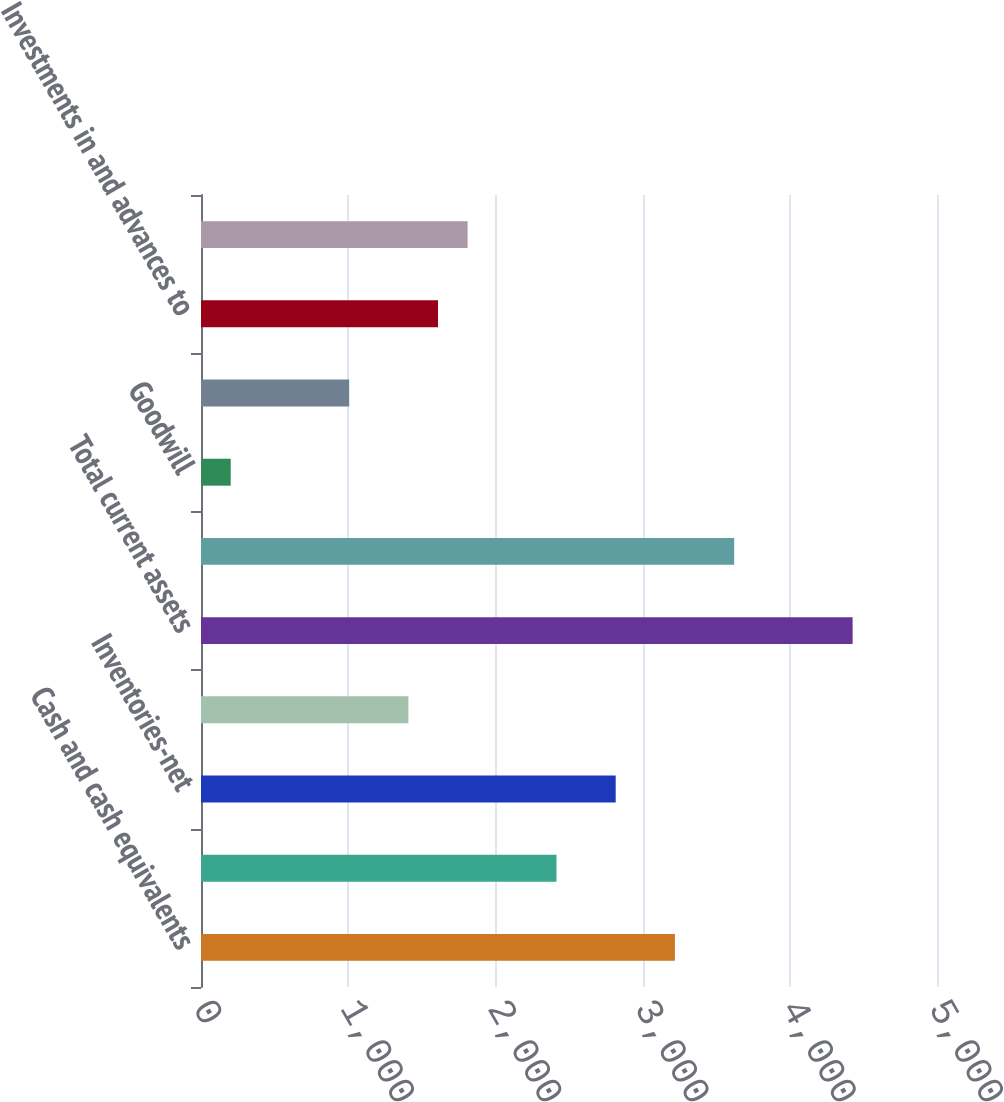<chart> <loc_0><loc_0><loc_500><loc_500><bar_chart><fcel>Cash and cash equivalents<fcel>Accounts receivable<fcel>Inventories-net<fcel>Other<fcel>Total current assets<fcel>Property plant and<fcel>Goodwill<fcel>Asset retirement obligation<fcel>Investments in and advances to<fcel>Other assets<nl><fcel>3219.64<fcel>2414.88<fcel>2817.26<fcel>1408.93<fcel>4426.78<fcel>3622.02<fcel>201.79<fcel>1006.55<fcel>1610.12<fcel>1811.31<nl></chart> 